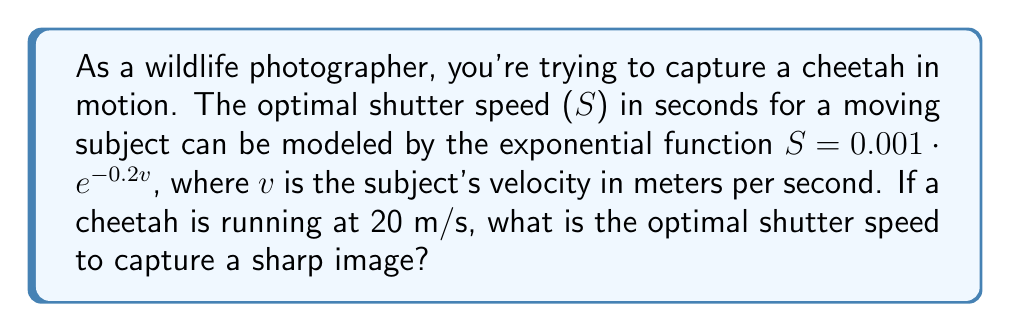Solve this math problem. To solve this problem, we'll follow these steps:

1. Identify the given information:
   - The exponential function for optimal shutter speed: $S = 0.001 \cdot e^{-0.2v}$
   - The cheetah's velocity: $v = 20$ m/s

2. Substitute the velocity into the equation:
   $S = 0.001 \cdot e^{-0.2(20)}$

3. Simplify the exponent:
   $S = 0.001 \cdot e^{-4}$

4. Calculate the value of $e^{-4}$:
   $e^{-4} \approx 0.0183$

5. Multiply by 0.001:
   $S = 0.001 \cdot 0.0183 \approx 0.0000183$

6. Convert to a more practical unit:
   $S \approx 1.83 \times 10^{-5}$ seconds, or 0.0183 milliseconds

Therefore, the optimal shutter speed for capturing a sharp image of a cheetah running at 20 m/s is approximately 1/54,645 of a second.
Answer: $1.83 \times 10^{-5}$ seconds 